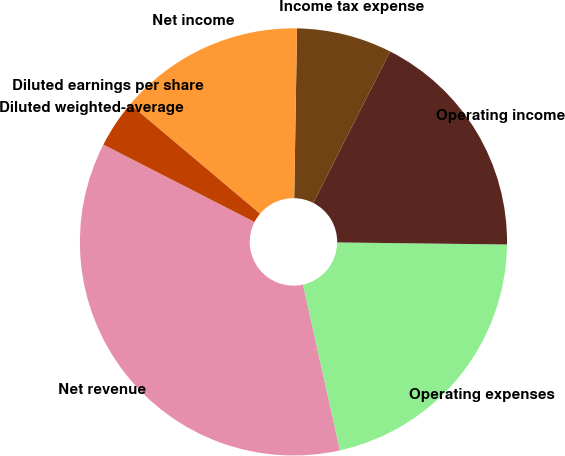Convert chart to OTSL. <chart><loc_0><loc_0><loc_500><loc_500><pie_chart><fcel>Net revenue<fcel>Operating expenses<fcel>Operating income<fcel>Income tax expense<fcel>Net income<fcel>Diluted earnings per share<fcel>Diluted weighted-average<nl><fcel>36.02%<fcel>21.31%<fcel>17.71%<fcel>7.21%<fcel>14.11%<fcel>0.01%<fcel>3.61%<nl></chart> 